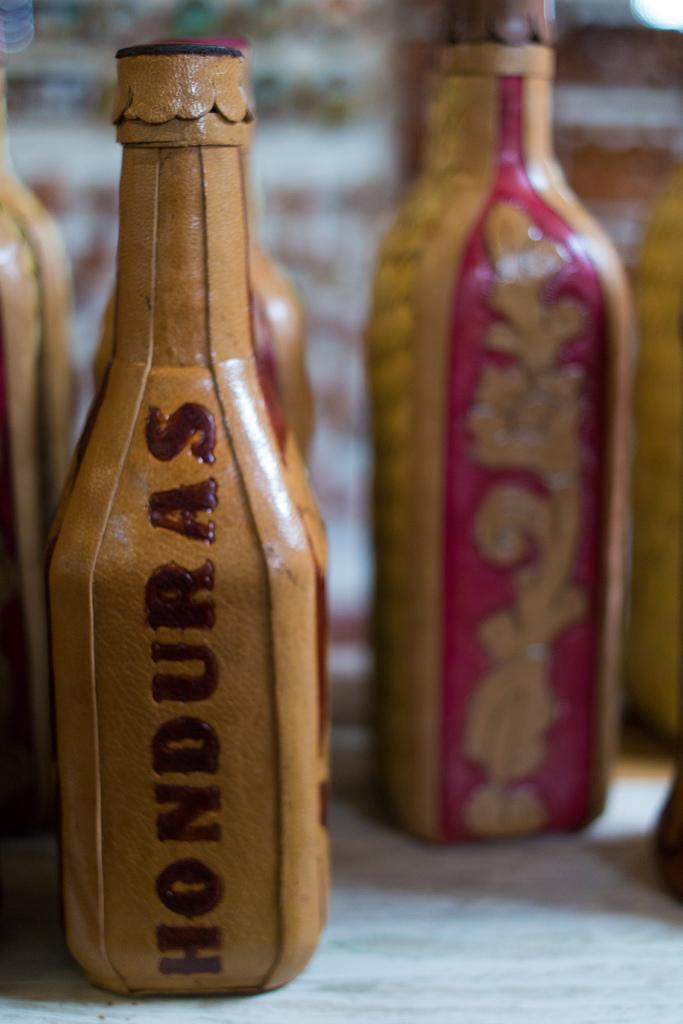Provide a one-sentence caption for the provided image. Leather covered bottles of which one says Honduras. 